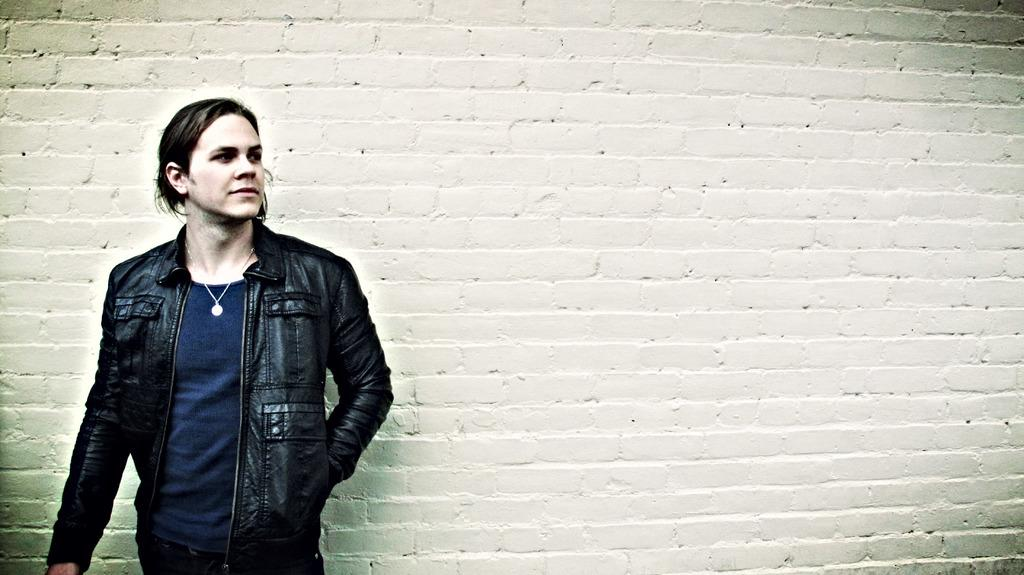What is the main subject on the left side of the image? There is a man standing on the left side of the image. What is the man wearing in the image? The man is wearing a jacket in the image. What can be seen in the background of the image? There is a wall in the background of the image. What type of transport is the man using to move around in the image? The image does not show the man using any type of transport to move around. 